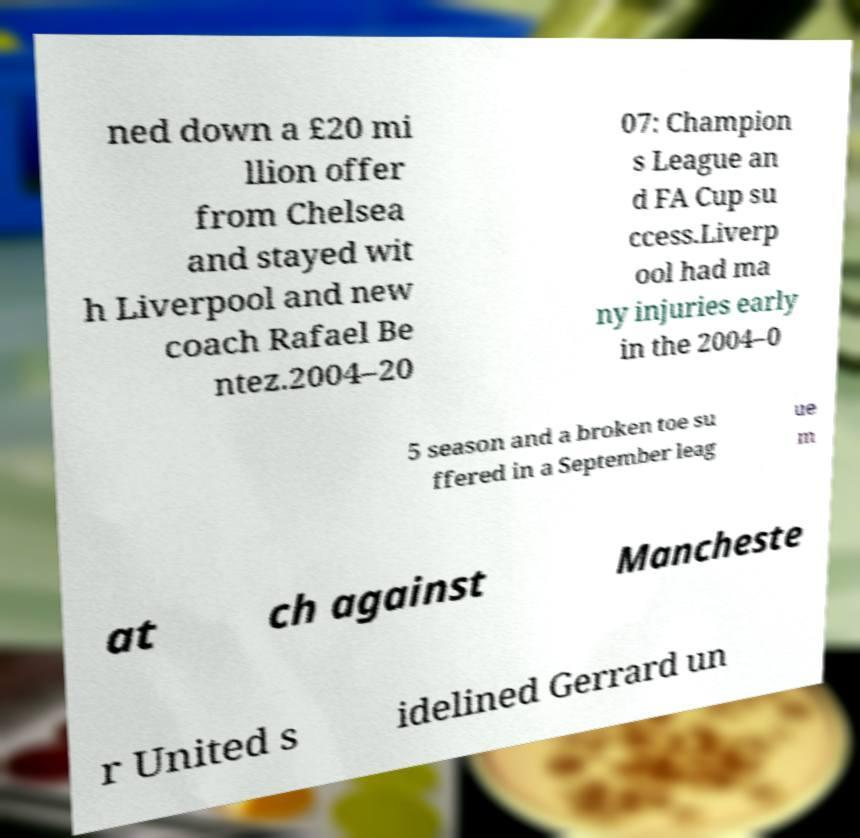Please read and relay the text visible in this image. What does it say? ned down a £20 mi llion offer from Chelsea and stayed wit h Liverpool and new coach Rafael Be ntez.2004–20 07: Champion s League an d FA Cup su ccess.Liverp ool had ma ny injuries early in the 2004–0 5 season and a broken toe su ffered in a September leag ue m at ch against Mancheste r United s idelined Gerrard un 